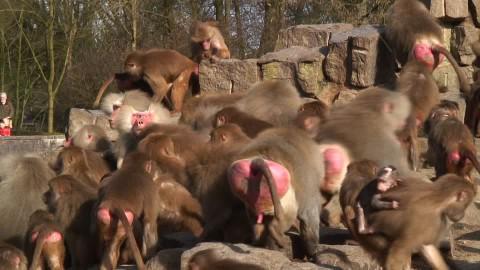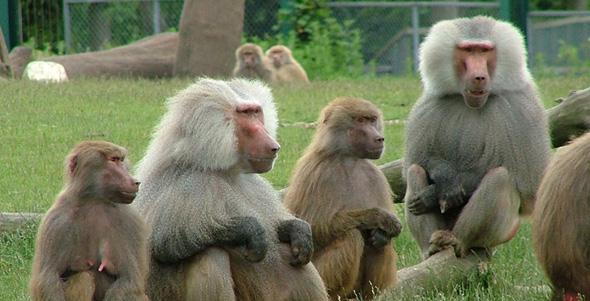The first image is the image on the left, the second image is the image on the right. Considering the images on both sides, is "The pink rear ends of several primates are visible." valid? Answer yes or no. Yes. The first image is the image on the left, the second image is the image on the right. For the images shown, is this caption "An image shows multiple rear-facing baboons with bulbous pink rears." true? Answer yes or no. Yes. 